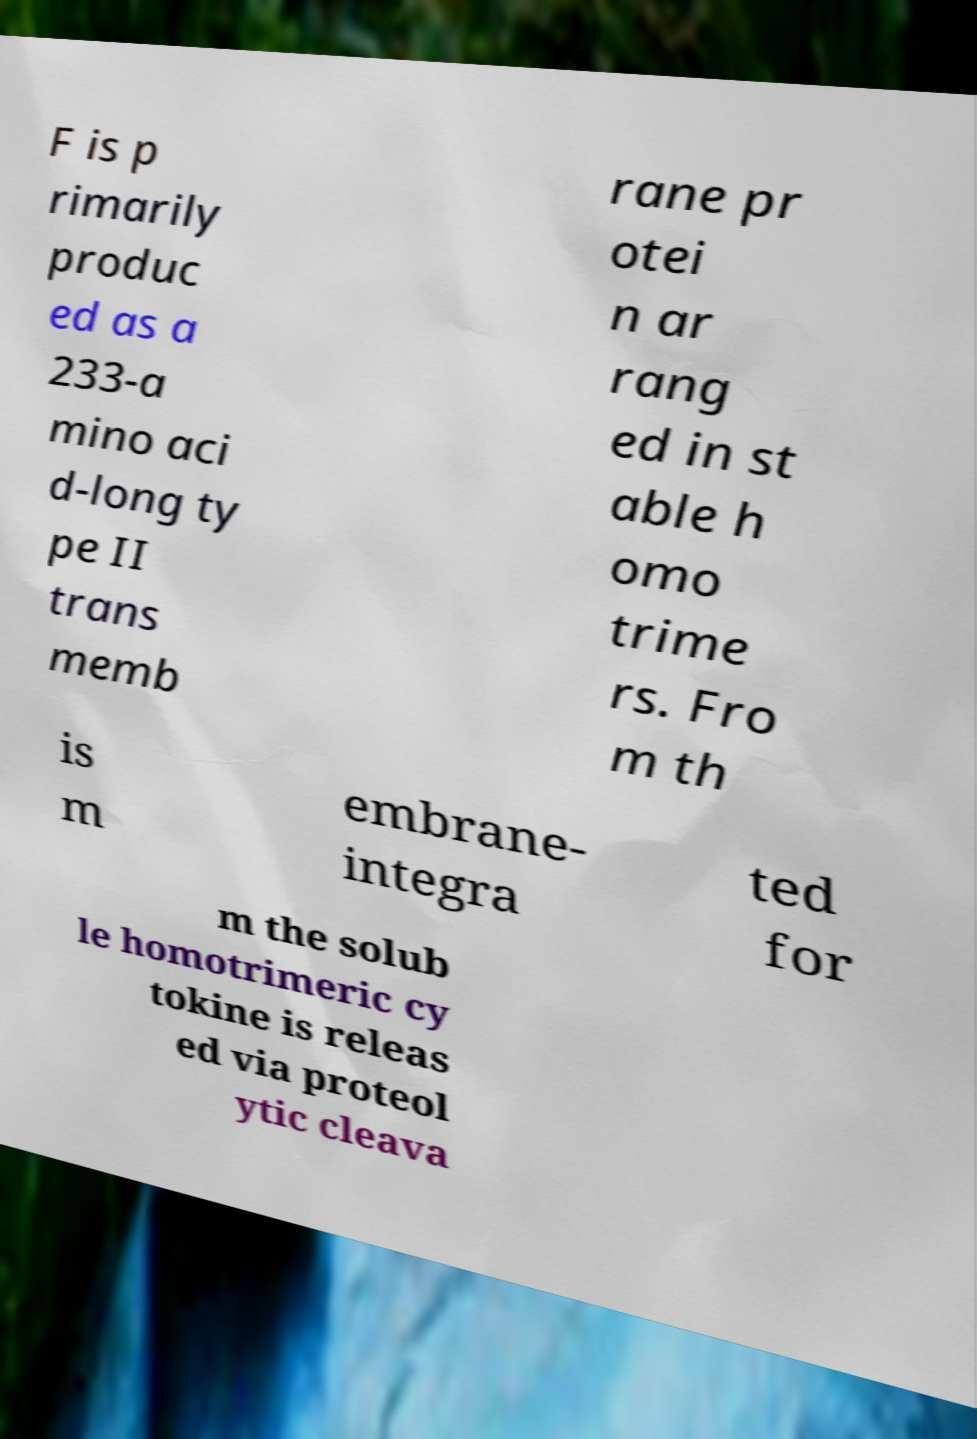Can you accurately transcribe the text from the provided image for me? F is p rimarily produc ed as a 233-a mino aci d-long ty pe II trans memb rane pr otei n ar rang ed in st able h omo trime rs. Fro m th is m embrane- integra ted for m the solub le homotrimeric cy tokine is releas ed via proteol ytic cleava 